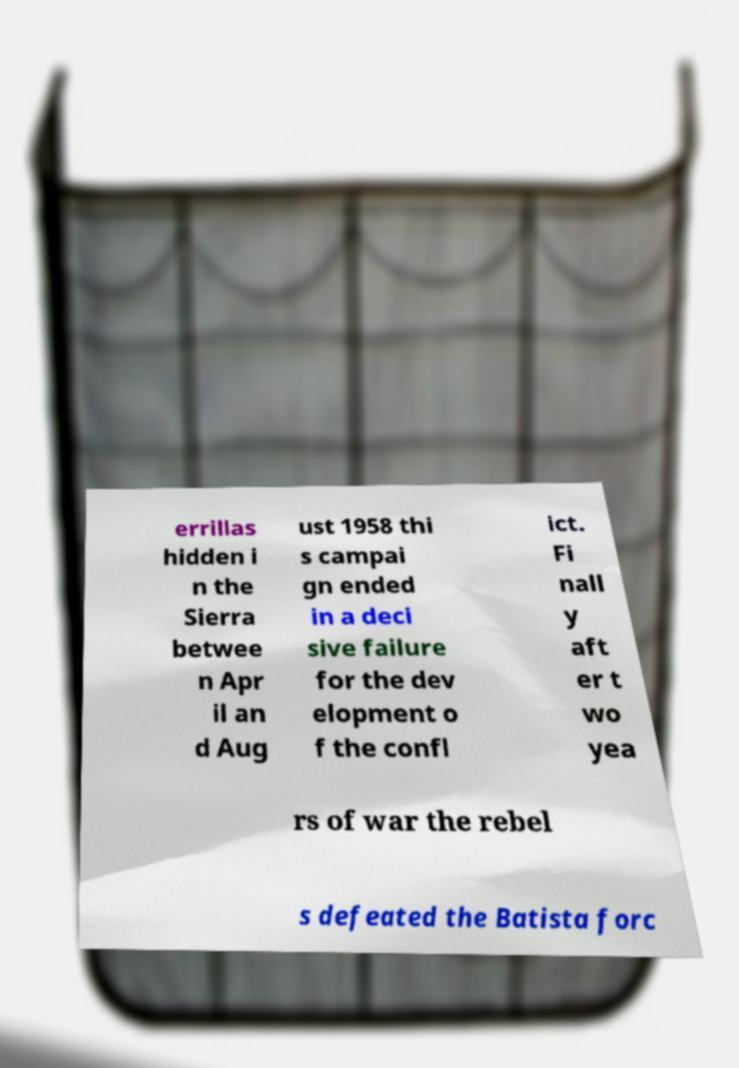What messages or text are displayed in this image? I need them in a readable, typed format. errillas hidden i n the Sierra betwee n Apr il an d Aug ust 1958 thi s campai gn ended in a deci sive failure for the dev elopment o f the confl ict. Fi nall y aft er t wo yea rs of war the rebel s defeated the Batista forc 